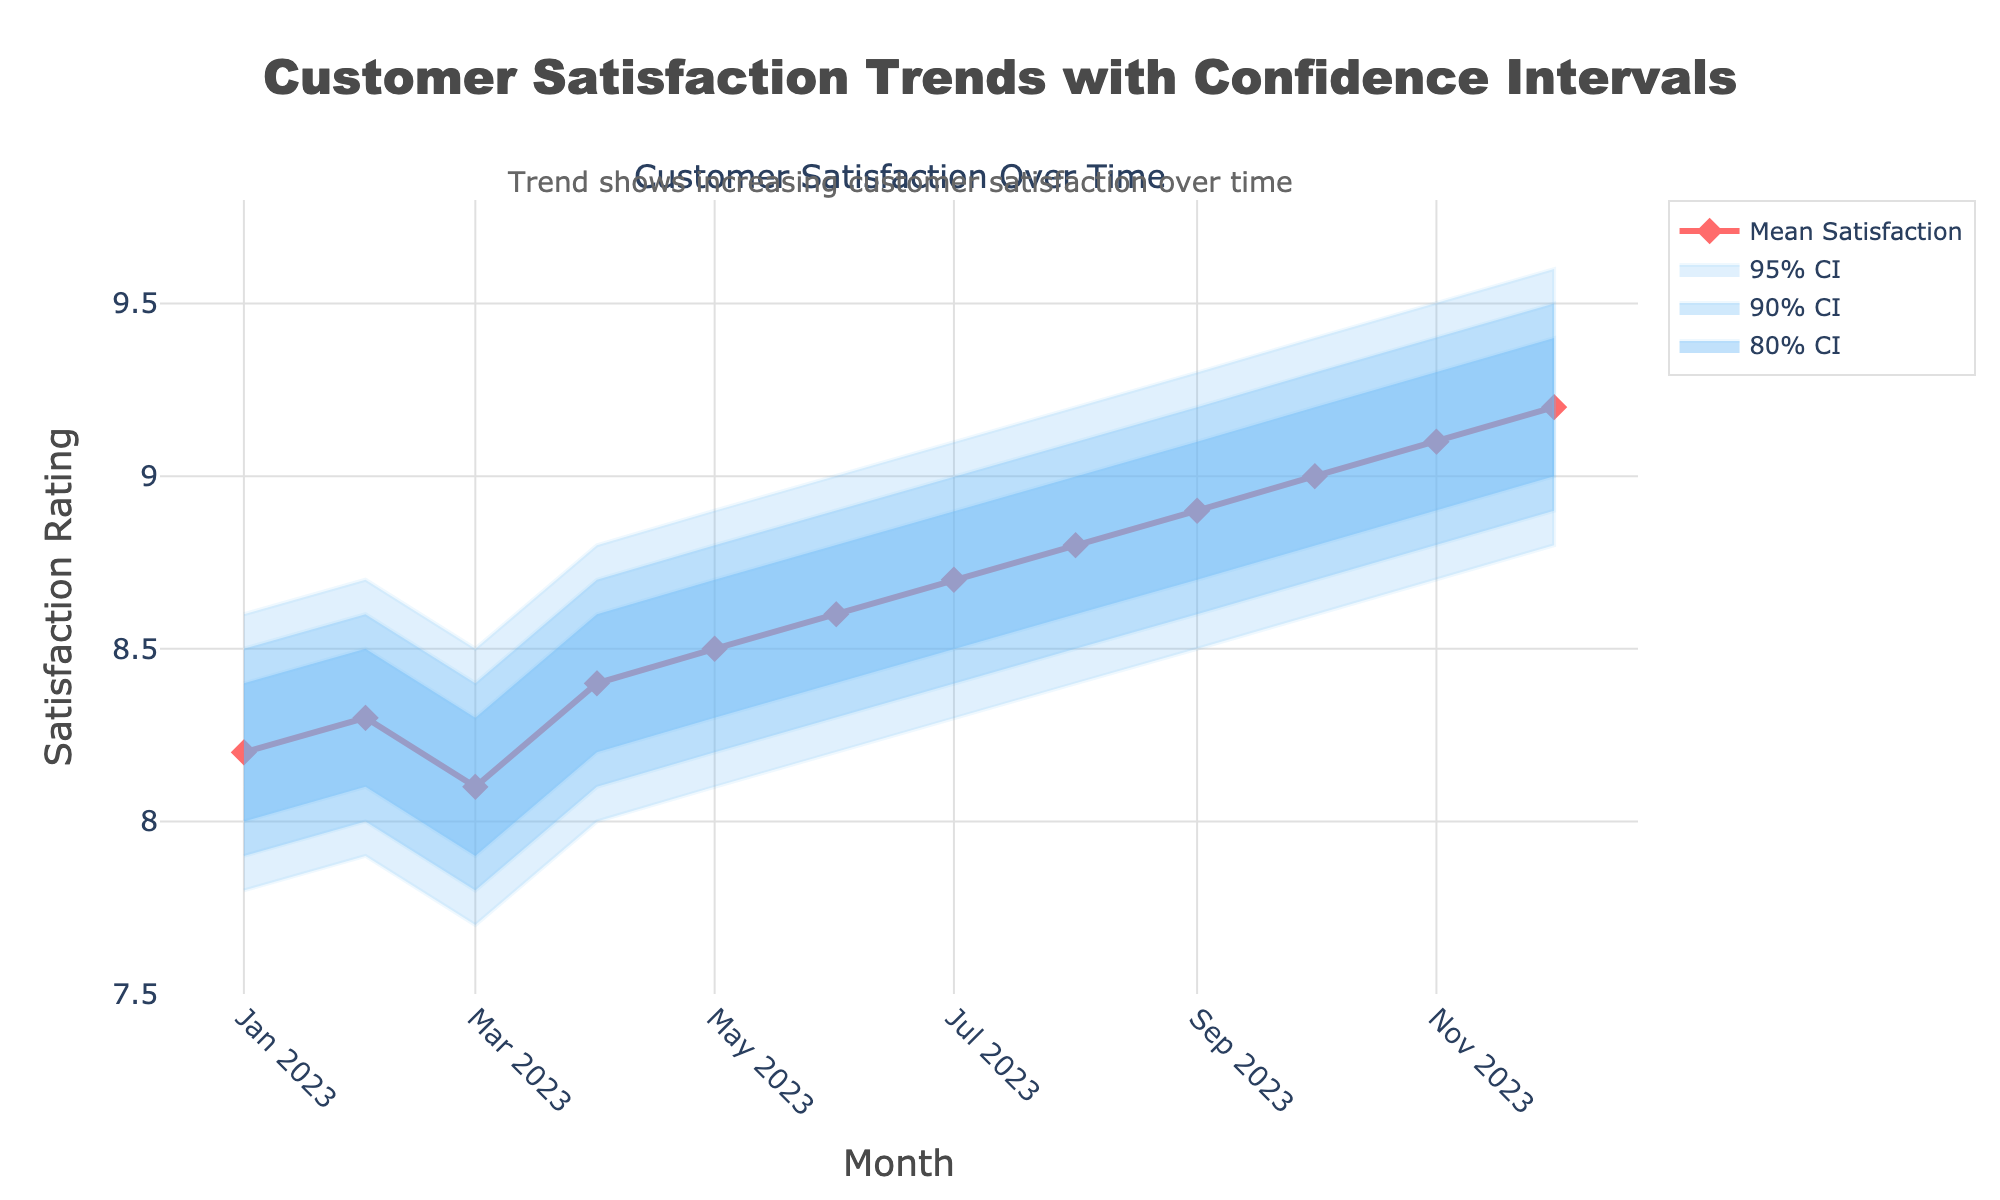What is the title of the chart? The title of the chart is displayed prominently at the top center, indicating the subject of the visual representation.
Answer: Customer Satisfaction Trends with Confidence Intervals What is the mean satisfaction rating in July 2023? Locate the month July 2023 on the x-axis and find the corresponding value on the mean satisfaction line.
Answer: 8.7 What is the trend of mean customer satisfaction from January 2023 to December 2023? Observe the line representing mean satisfaction ratings over time. The trend can be identified by the overall direction of this line from the beginning to the end of the year.
Answer: Increasing Which month has the highest mean satisfaction rating? Compare the mean satisfaction values for all months and identify the highest one.
Answer: December 2023 How has the confidence interval changed over time? Analyze the width of the shaded areas representing the confidence intervals for each period. Observe whether the intervals are narrowing or widening over time.
Answer: Intervals are widening What is the difference in mean satisfaction ratings between January 2023 and December 2023? Subtract the mean satisfaction rating of January 2023 from December 2023.
Answer: 1 In which month did the lower bound of the 95% confidence interval reach its peak? Look for the highest value in the lower bound of the 95% confidence interval across all months.
Answer: December 2023 How do the 80%, 90%, and 95% confidence intervals visually compare? Examine the shaded regions corresponding to 80%, 90%, and 95% confidence intervals and note differences in their width and transparency.
Answer: 80% CI is narrowest and darkest; 90% CI is wider and lighter; 95% CI is widest and lightest Is there any month where the mean satisfaction is below 8? Trace the mean satisfaction line to see if it dips below 8 at any point along the timeline.
Answer: No How does the satisfaction rating in April 2023 compare to June 2023? Compare the values on the mean satisfaction line for April 2023 and June 2023 to determine which is higher.
Answer: June 2023 is higher 